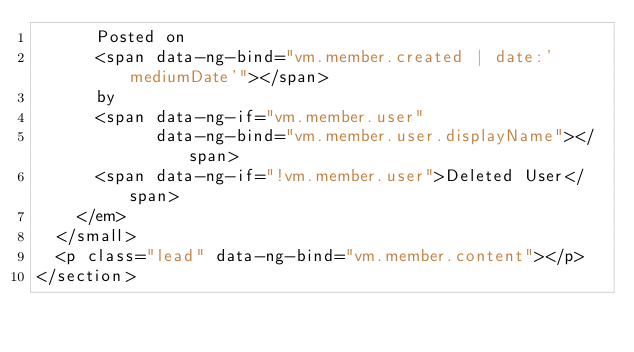<code> <loc_0><loc_0><loc_500><loc_500><_HTML_>      Posted on
      <span data-ng-bind="vm.member.created | date:'mediumDate'"></span>
      by
      <span data-ng-if="vm.member.user"
            data-ng-bind="vm.member.user.displayName"></span>
      <span data-ng-if="!vm.member.user">Deleted User</span>
    </em>
  </small>
  <p class="lead" data-ng-bind="vm.member.content"></p>
</section>
</code> 